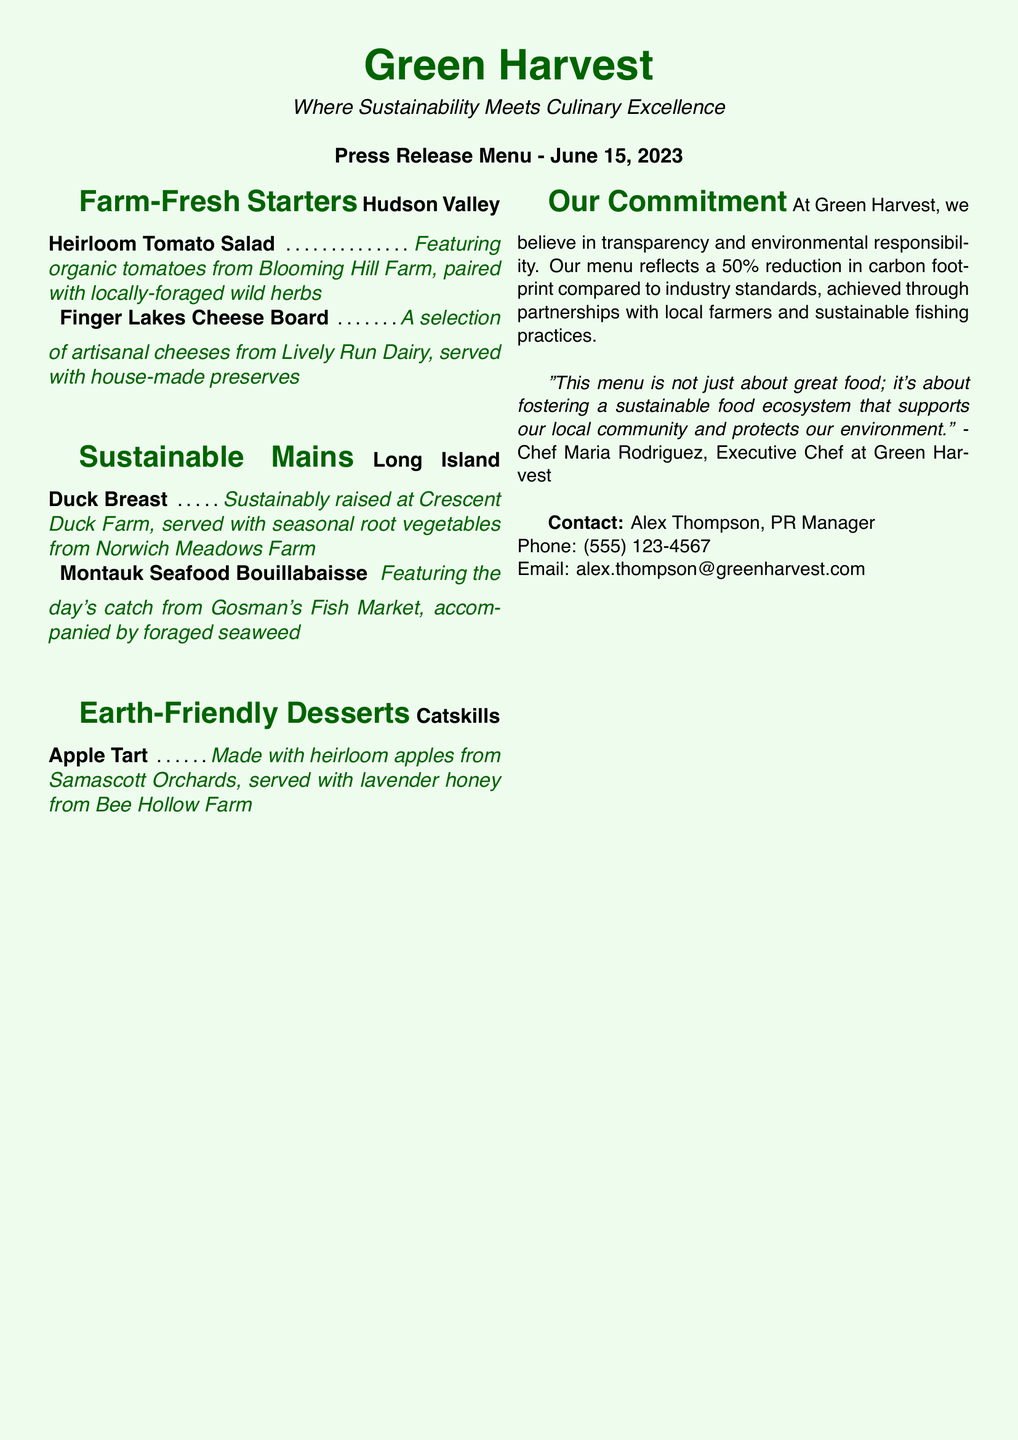What is the restaurant's name? The restaurant's name is prominently featured at the top of the document.
Answer: Green Harvest What type of menu is presented? The document identifies the type of menu as a specific format for announcing news regarding the restaurant's offerings.
Answer: Press Release Menu Who is the Executive Chef? The name of the executive chef is mentioned in a quote within the document, showcasing the restaurant's philosophy.
Answer: Chef Maria Rodriguez What date was this press release menu issued? The date appears clearly on the menu itself, indicating when it was published.
Answer: June 15, 2023 How many farm-fresh starters are listed? The document lists specific items under the "Farm-Fresh Starters" section, which can be counted.
Answer: 2 What is the source of the cheese in the Finger Lakes Cheese Board? The specific farm that provides the cheese is mentioned in the item description.
Answer: Lively Run Dairy What is the main ingredient in the Montauk Seafood Bouillabaisse? The main ingredient is outlined in the description of the dish on the menu.
Answer: Day's catch What percentage reduction in carbon footprint does the restaurant achieve? The main commitment of the restaurant regarding sustainability is stated with a specific percentage.
Answer: 50% What kind of honey is served with the Catskills Apple Tart? The description specifies the type of honey used in the dessert item.
Answer: Lavender honey 